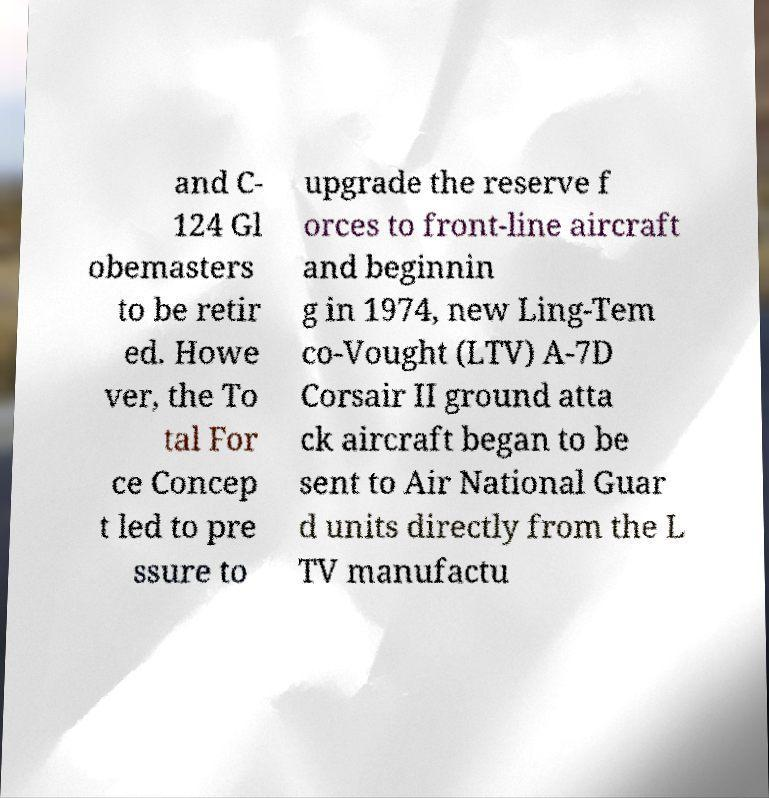I need the written content from this picture converted into text. Can you do that? and C- 124 Gl obemasters to be retir ed. Howe ver, the To tal For ce Concep t led to pre ssure to upgrade the reserve f orces to front-line aircraft and beginnin g in 1974, new Ling-Tem co-Vought (LTV) A-7D Corsair II ground atta ck aircraft began to be sent to Air National Guar d units directly from the L TV manufactu 